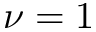<formula> <loc_0><loc_0><loc_500><loc_500>\nu = 1</formula> 